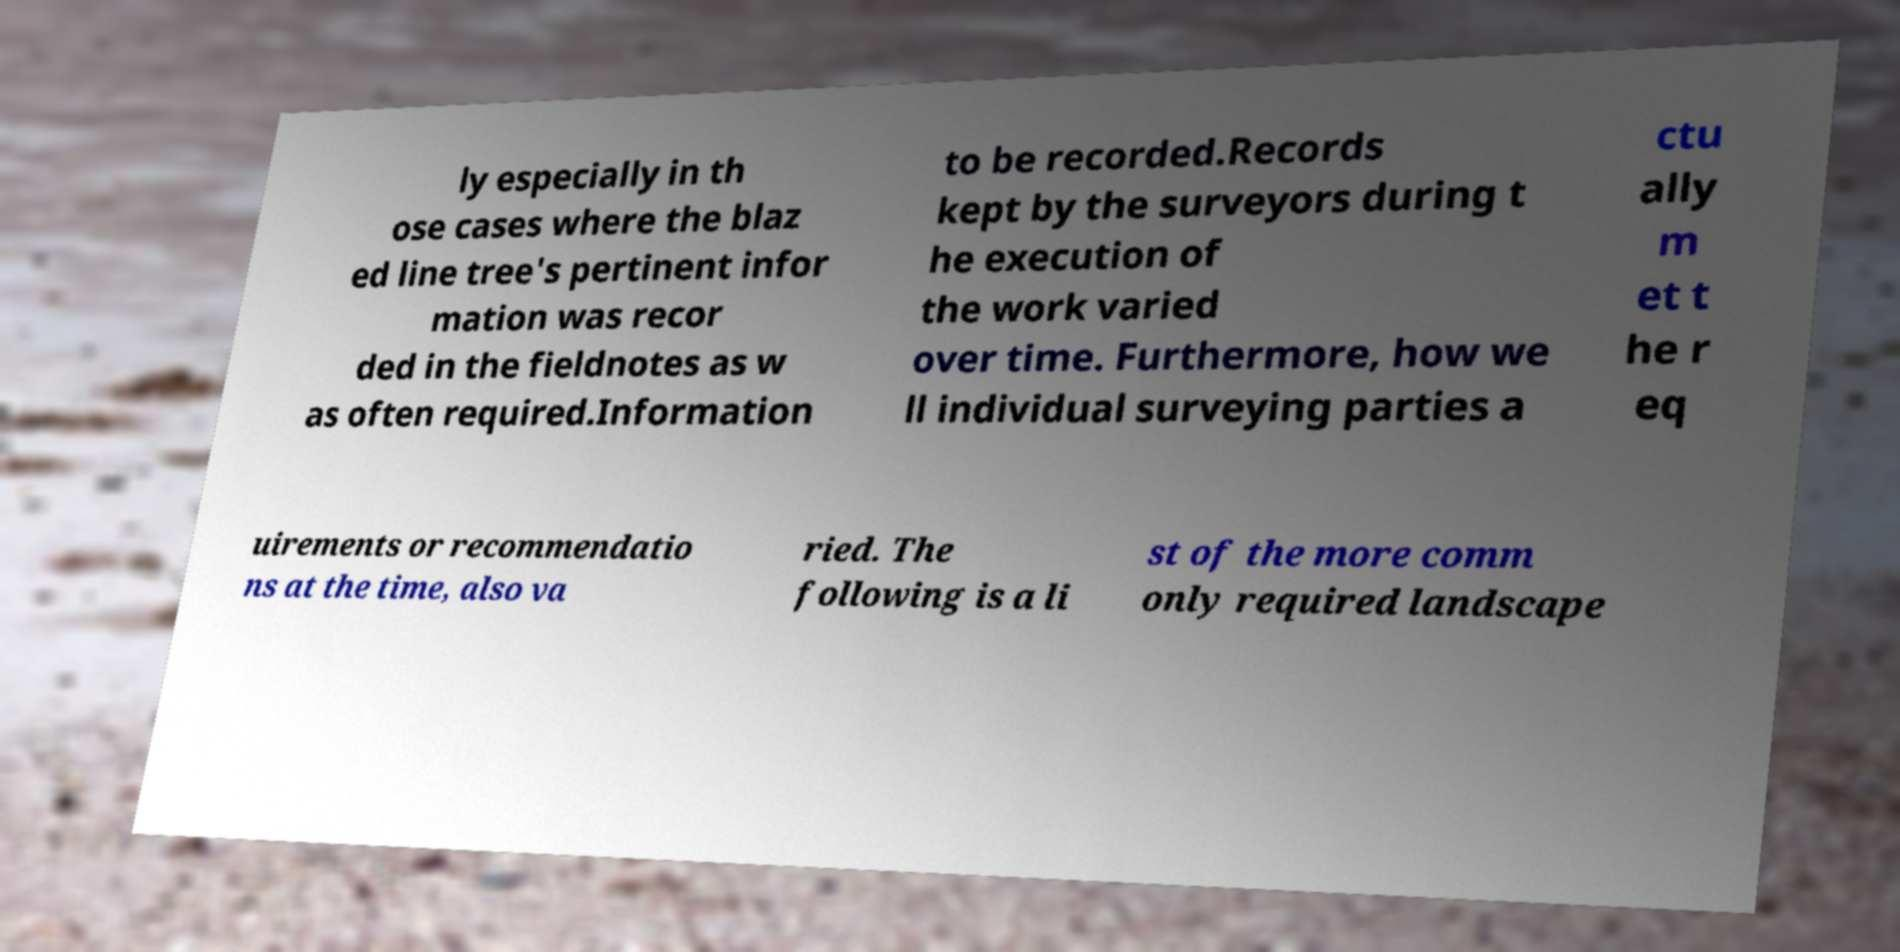Can you accurately transcribe the text from the provided image for me? ly especially in th ose cases where the blaz ed line tree's pertinent infor mation was recor ded in the fieldnotes as w as often required.Information to be recorded.Records kept by the surveyors during t he execution of the work varied over time. Furthermore, how we ll individual surveying parties a ctu ally m et t he r eq uirements or recommendatio ns at the time, also va ried. The following is a li st of the more comm only required landscape 